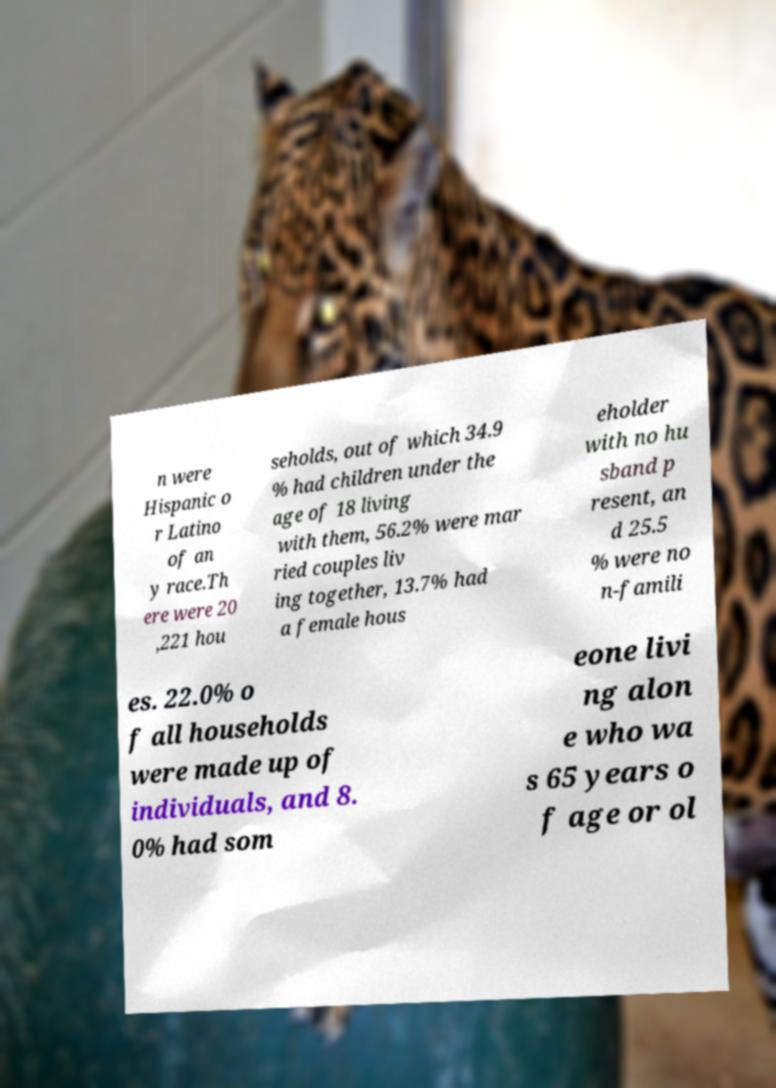Can you read and provide the text displayed in the image?This photo seems to have some interesting text. Can you extract and type it out for me? n were Hispanic o r Latino of an y race.Th ere were 20 ,221 hou seholds, out of which 34.9 % had children under the age of 18 living with them, 56.2% were mar ried couples liv ing together, 13.7% had a female hous eholder with no hu sband p resent, an d 25.5 % were no n-famili es. 22.0% o f all households were made up of individuals, and 8. 0% had som eone livi ng alon e who wa s 65 years o f age or ol 